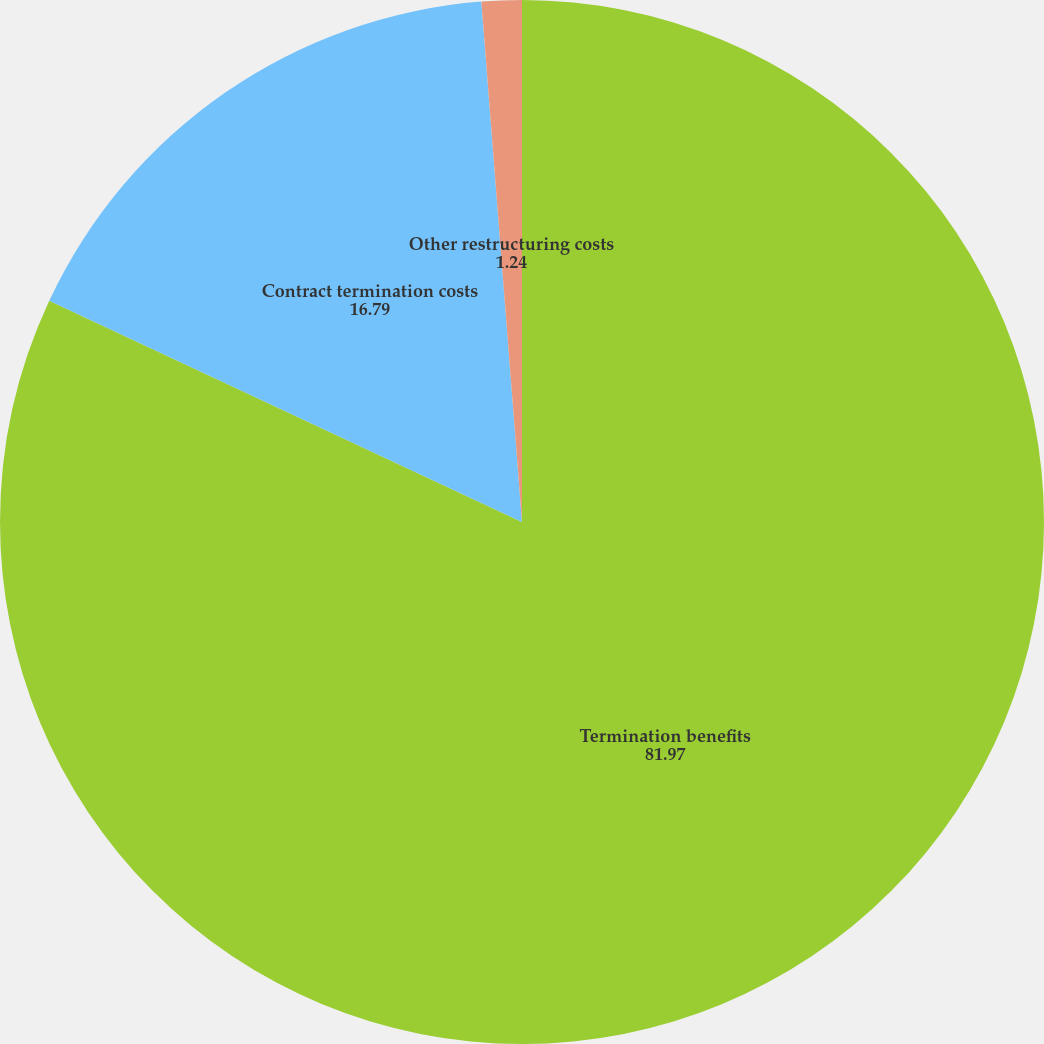<chart> <loc_0><loc_0><loc_500><loc_500><pie_chart><fcel>Termination benefits<fcel>Contract termination costs<fcel>Other restructuring costs<nl><fcel>81.97%<fcel>16.79%<fcel>1.24%<nl></chart> 